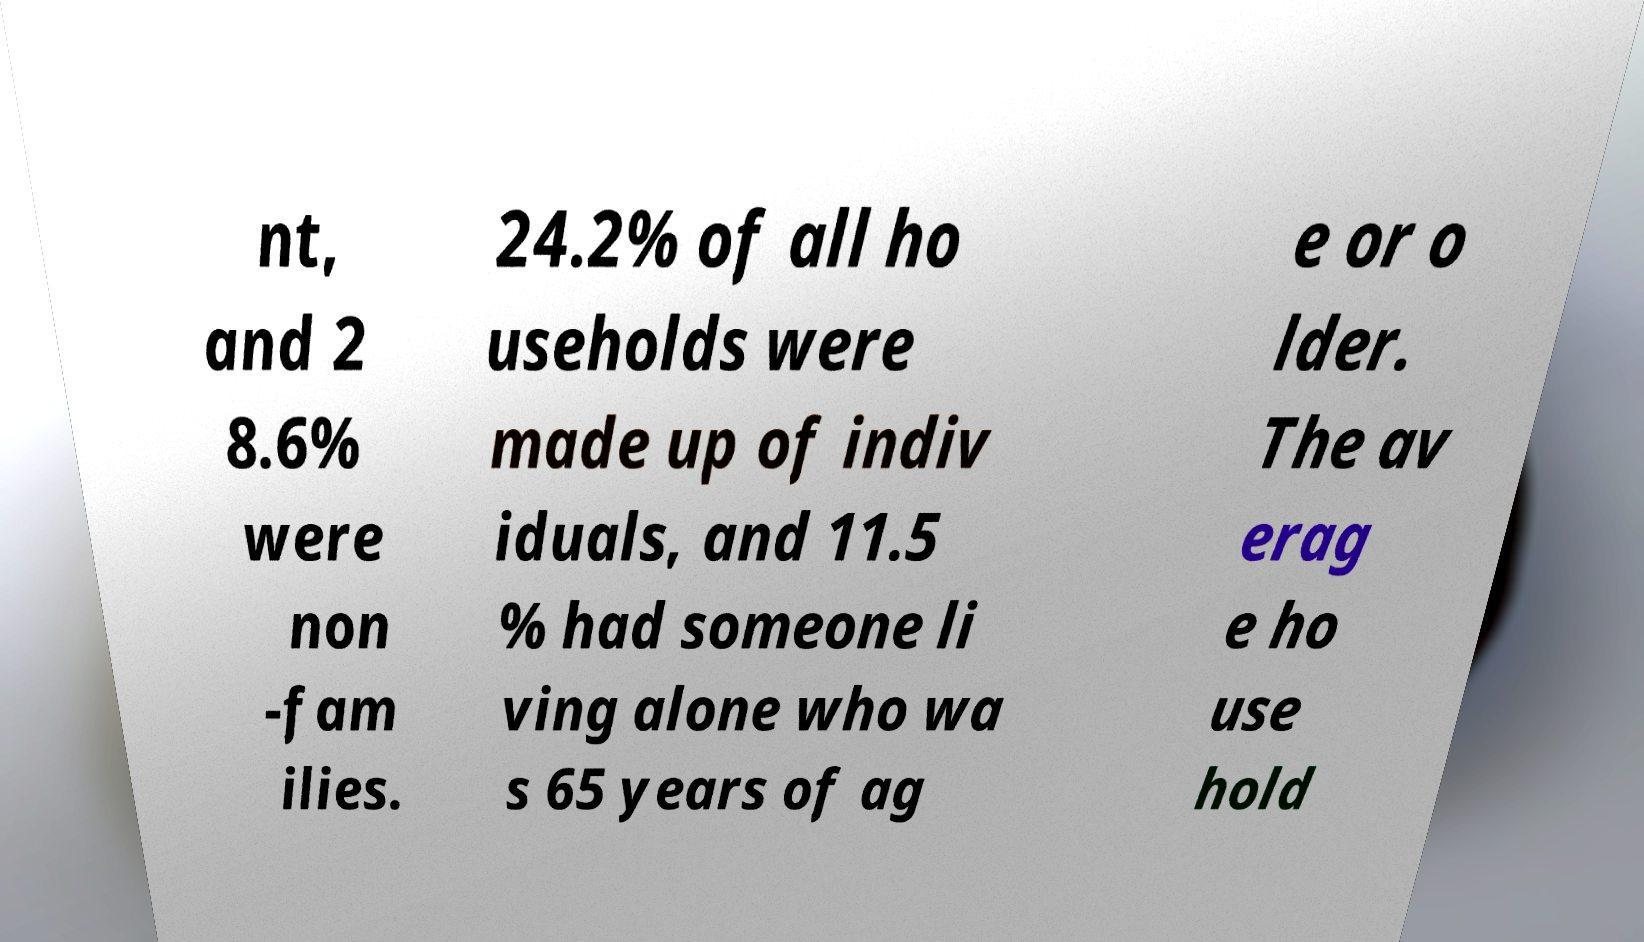For documentation purposes, I need the text within this image transcribed. Could you provide that? nt, and 2 8.6% were non -fam ilies. 24.2% of all ho useholds were made up of indiv iduals, and 11.5 % had someone li ving alone who wa s 65 years of ag e or o lder. The av erag e ho use hold 